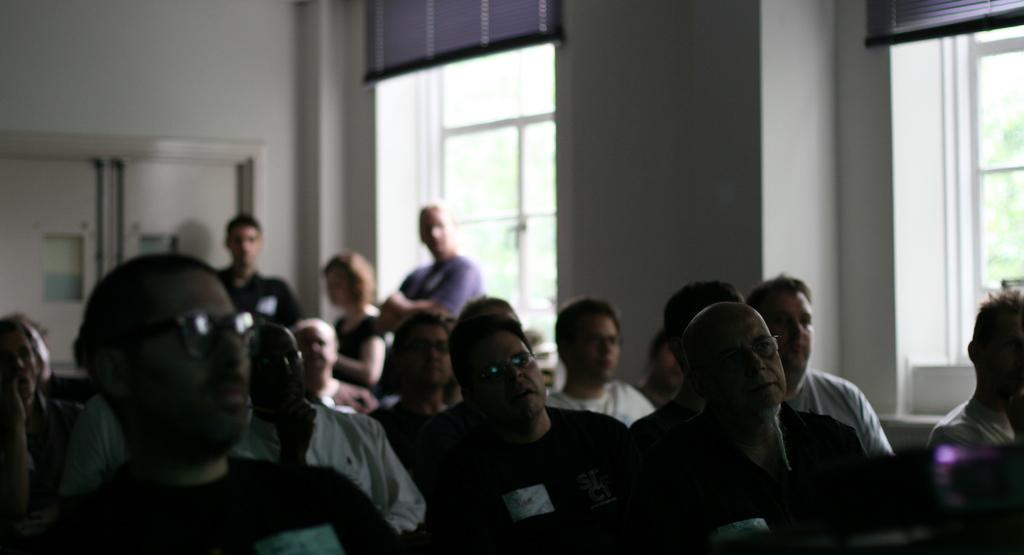How many people are in the image? There are people in the image, but the exact number is not specified. What are the people in the image doing? Some people are standing, while others are sitting. What can be seen in the background of the image? There is a wall, windows, and doors in the background of the image. How is the background of the image depicted? The background of the image is blurred. What suggestion is being made by the person walking on the sidewalk in the image? There is no person walking on the sidewalk in the image, and therefore no suggestion can be made. How quiet is the environment in the image? The image does not provide any information about the noise level or the environment's quietness. 